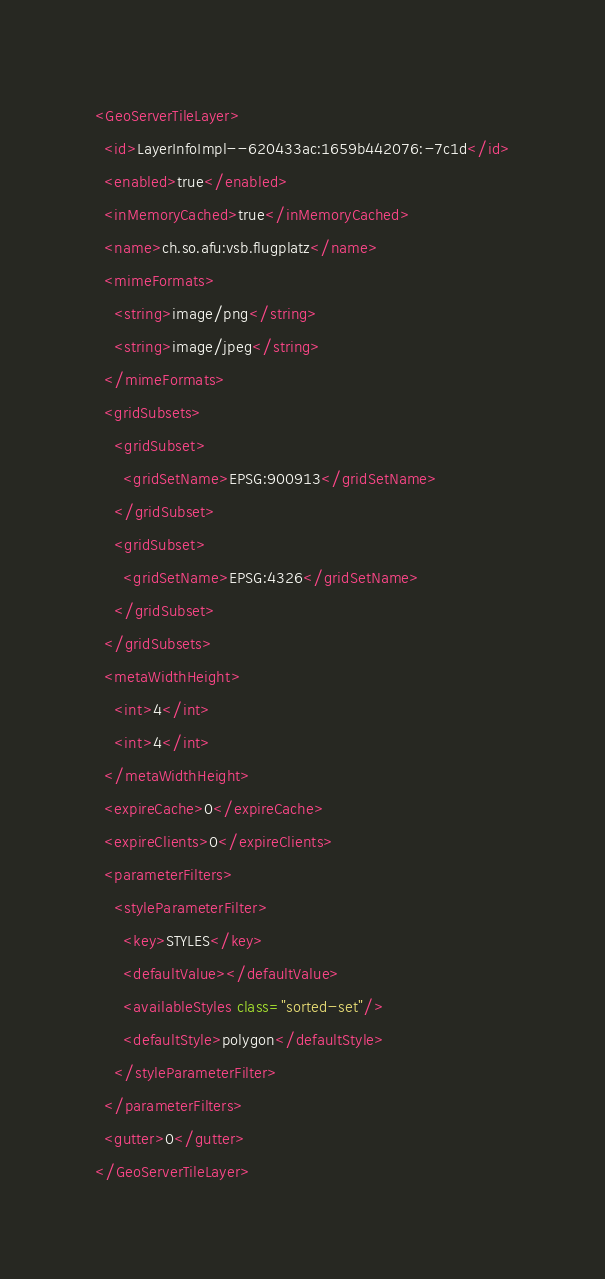<code> <loc_0><loc_0><loc_500><loc_500><_XML_><GeoServerTileLayer>
  <id>LayerInfoImpl--620433ac:1659b442076:-7c1d</id>
  <enabled>true</enabled>
  <inMemoryCached>true</inMemoryCached>
  <name>ch.so.afu:vsb.flugplatz</name>
  <mimeFormats>
    <string>image/png</string>
    <string>image/jpeg</string>
  </mimeFormats>
  <gridSubsets>
    <gridSubset>
      <gridSetName>EPSG:900913</gridSetName>
    </gridSubset>
    <gridSubset>
      <gridSetName>EPSG:4326</gridSetName>
    </gridSubset>
  </gridSubsets>
  <metaWidthHeight>
    <int>4</int>
    <int>4</int>
  </metaWidthHeight>
  <expireCache>0</expireCache>
  <expireClients>0</expireClients>
  <parameterFilters>
    <styleParameterFilter>
      <key>STYLES</key>
      <defaultValue></defaultValue>
      <availableStyles class="sorted-set"/>
      <defaultStyle>polygon</defaultStyle>
    </styleParameterFilter>
  </parameterFilters>
  <gutter>0</gutter>
</GeoServerTileLayer></code> 